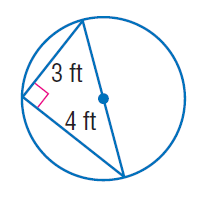Answer the mathemtical geometry problem and directly provide the correct option letter.
Question: Find the exact circumference of the circle.
Choices: A: 2.5 \pi B: 15 C: 5 \pi D: 10 \pi C 